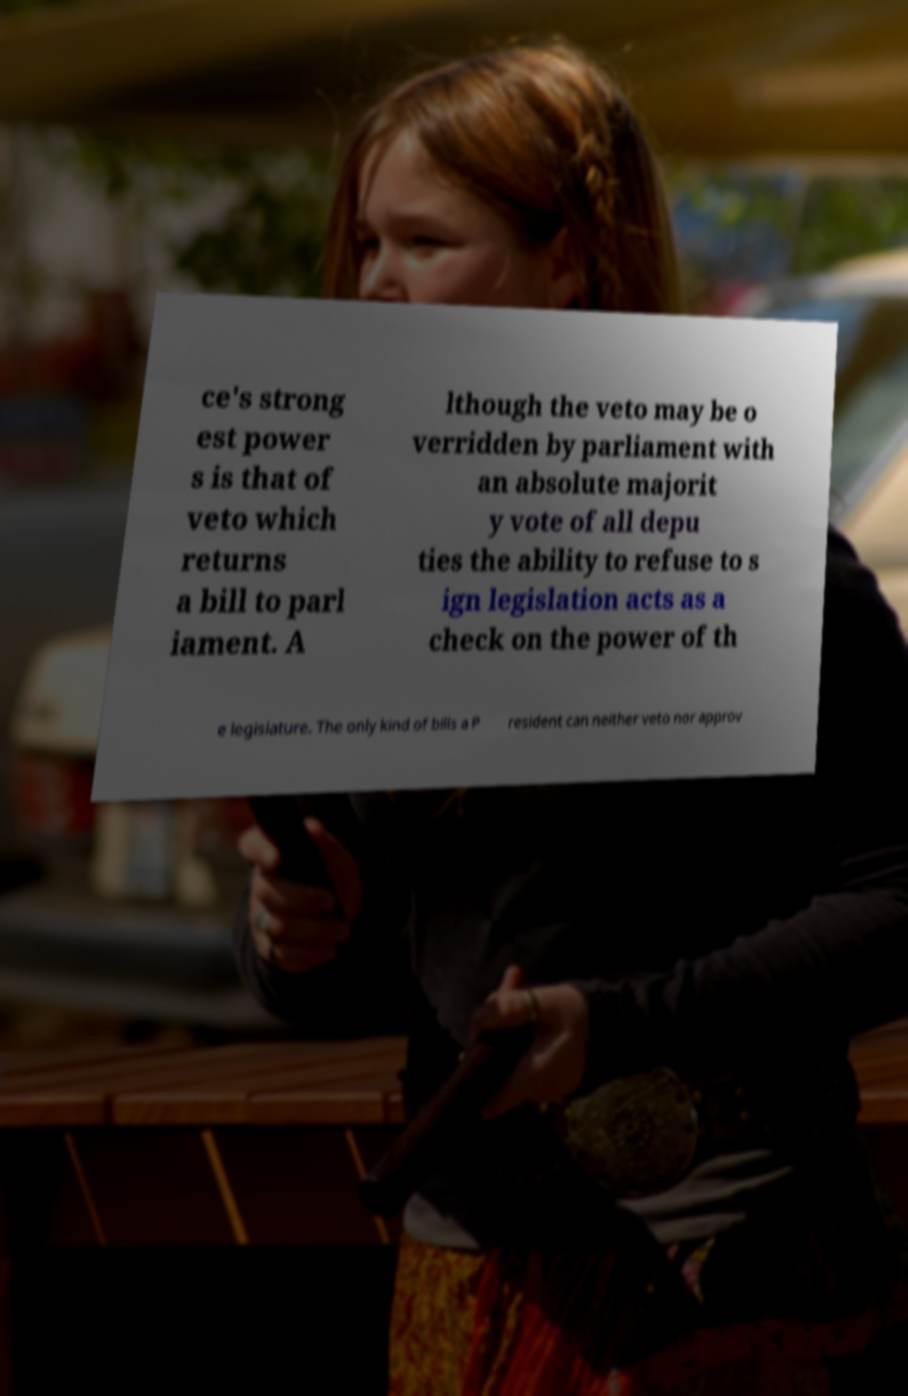There's text embedded in this image that I need extracted. Can you transcribe it verbatim? ce's strong est power s is that of veto which returns a bill to parl iament. A lthough the veto may be o verridden by parliament with an absolute majorit y vote of all depu ties the ability to refuse to s ign legislation acts as a check on the power of th e legislature. The only kind of bills a P resident can neither veto nor approv 